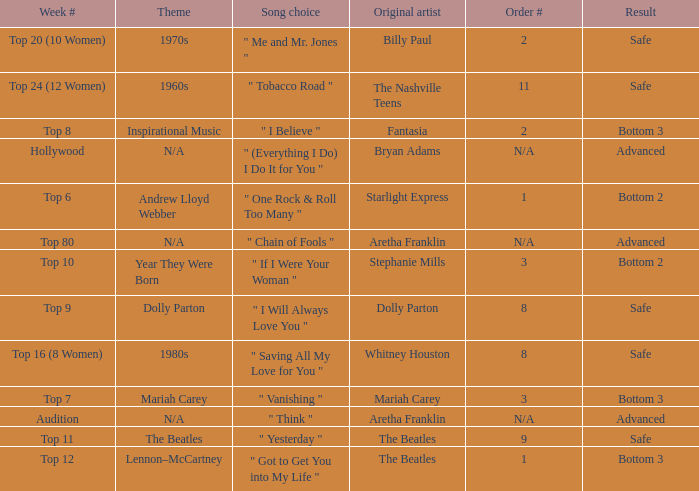Name the order number for the beatles and result is safe 9.0. 